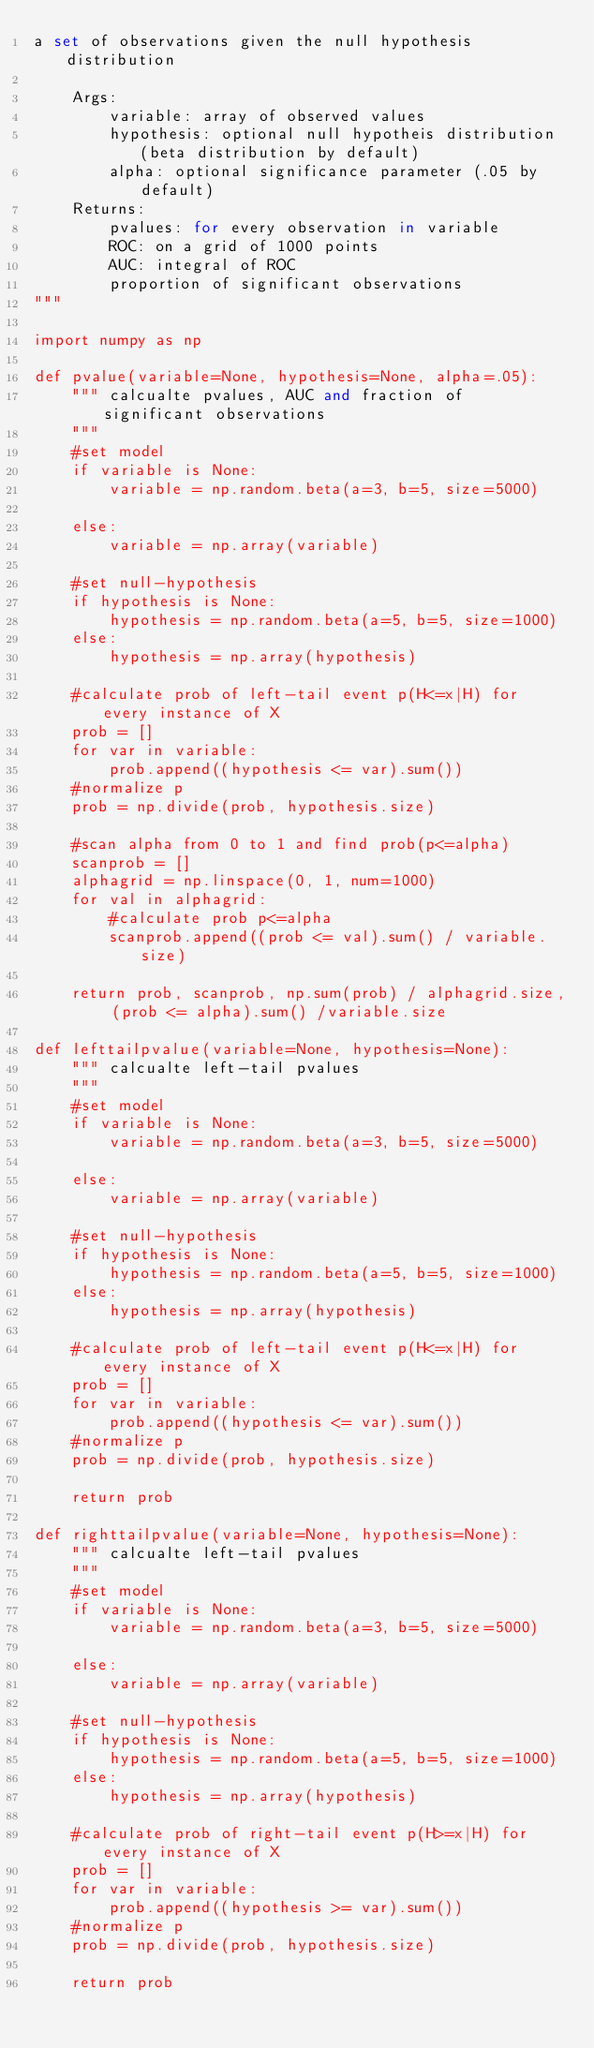<code> <loc_0><loc_0><loc_500><loc_500><_Python_>a set of observations given the null hypothesis distribution

    Args:
        variable: array of observed values
        hypothesis: optional null hypotheis distribution (beta distribution by default)
        alpha: optional significance parameter (.05 by default)
    Returns:
        pvalues: for every observation in variable
        ROC: on a grid of 1000 points
        AUC: integral of ROC
        proportion of significant observations
"""

import numpy as np

def pvalue(variable=None, hypothesis=None, alpha=.05):
    """ calcualte pvalues, AUC and fraction of significant observations
    """
    #set model
    if variable is None:
        variable = np.random.beta(a=3, b=5, size=5000)

    else:
        variable = np.array(variable)

    #set null-hypothesis
    if hypothesis is None:
        hypothesis = np.random.beta(a=5, b=5, size=1000)
    else:
        hypothesis = np.array(hypothesis)

    #calculate prob of left-tail event p(H<=x|H) for every instance of X
    prob = []
    for var in variable:
        prob.append((hypothesis <= var).sum())
    #normalize p
    prob = np.divide(prob, hypothesis.size)

    #scan alpha from 0 to 1 and find prob(p<=alpha)
    scanprob = []
    alphagrid = np.linspace(0, 1, num=1000)
    for val in alphagrid:
        #calculate prob p<=alpha
        scanprob.append((prob <= val).sum() / variable.size)

    return prob, scanprob, np.sum(prob) / alphagrid.size, (prob <= alpha).sum() /variable.size

def lefttailpvalue(variable=None, hypothesis=None):
    """ calcualte left-tail pvalues
    """
    #set model
    if variable is None:
        variable = np.random.beta(a=3, b=5, size=5000)

    else:
        variable = np.array(variable)

    #set null-hypothesis
    if hypothesis is None:
        hypothesis = np.random.beta(a=5, b=5, size=1000)
    else:
        hypothesis = np.array(hypothesis)

    #calculate prob of left-tail event p(H<=x|H) for every instance of X
    prob = []
    for var in variable:
        prob.append((hypothesis <= var).sum())
    #normalize p
    prob = np.divide(prob, hypothesis.size)

    return prob

def righttailpvalue(variable=None, hypothesis=None):
    """ calcualte left-tail pvalues
    """
    #set model
    if variable is None:
        variable = np.random.beta(a=3, b=5, size=5000)

    else:
        variable = np.array(variable)

    #set null-hypothesis
    if hypothesis is None:
        hypothesis = np.random.beta(a=5, b=5, size=1000)
    else:
        hypothesis = np.array(hypothesis)

    #calculate prob of right-tail event p(H>=x|H) for every instance of X
    prob = []
    for var in variable:
        prob.append((hypothesis >= var).sum())
    #normalize p
    prob = np.divide(prob, hypothesis.size)

    return prob
</code> 